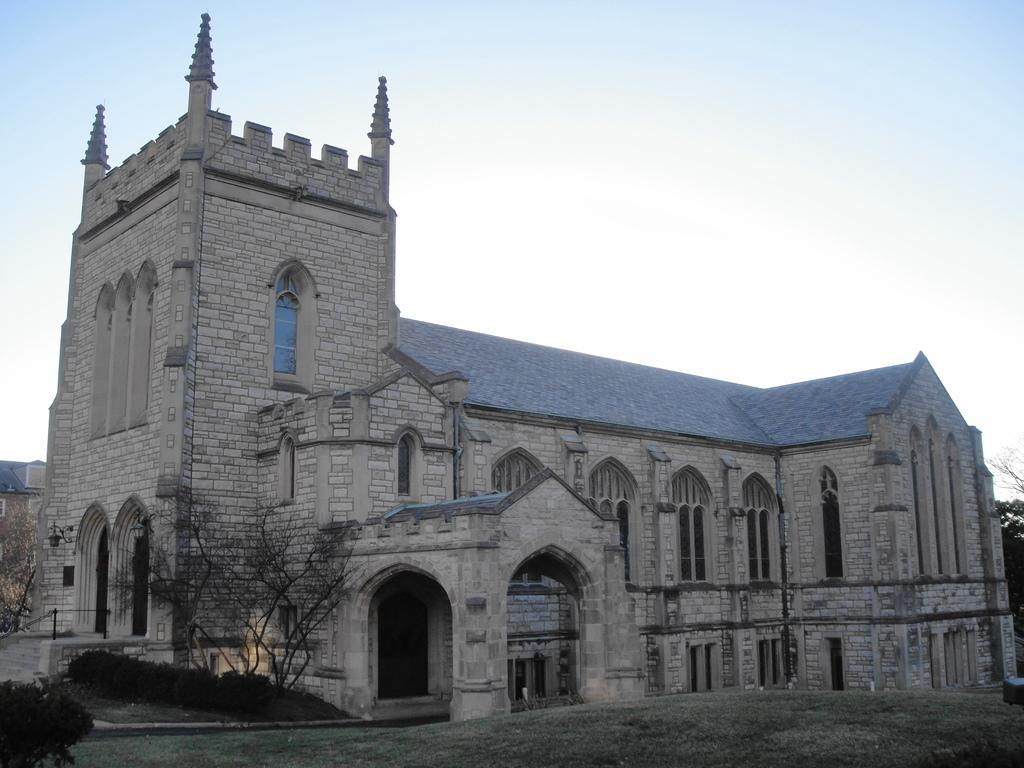What is the main structure in the image? There is a big building in the image. What type of vegetation can be seen in the image? There are plants and small trees in the image. What is covering the ground in the image? There is grass on the ground in the image. What year is the maid mentioned in the image? There is no mention of a maid or any specific year in the image. 